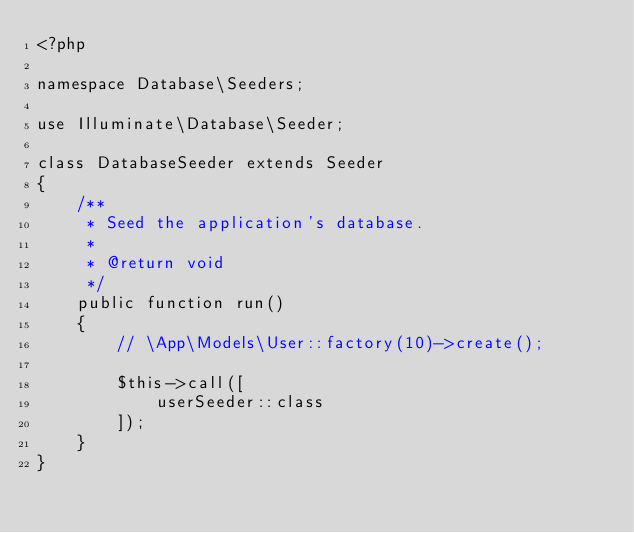Convert code to text. <code><loc_0><loc_0><loc_500><loc_500><_PHP_><?php

namespace Database\Seeders;

use Illuminate\Database\Seeder;

class DatabaseSeeder extends Seeder
{
    /**
     * Seed the application's database.
     *
     * @return void
     */
    public function run()
    {
        // \App\Models\User::factory(10)->create();

        $this->call([
            userSeeder::class
        ]);
    }
}
</code> 